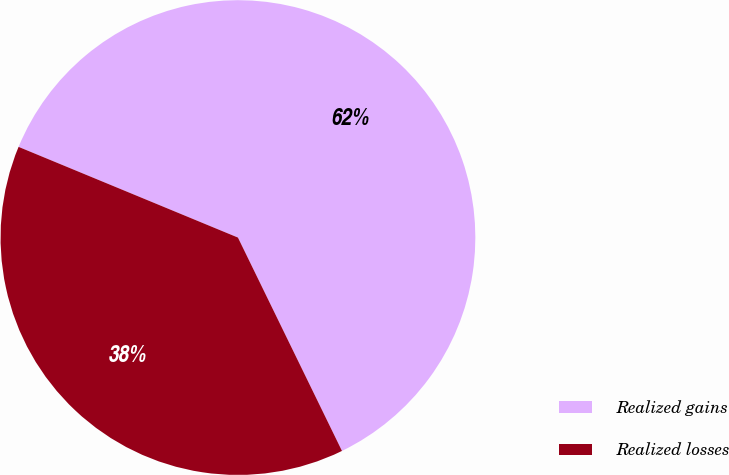Convert chart to OTSL. <chart><loc_0><loc_0><loc_500><loc_500><pie_chart><fcel>Realized gains<fcel>Realized losses<nl><fcel>61.54%<fcel>38.46%<nl></chart> 